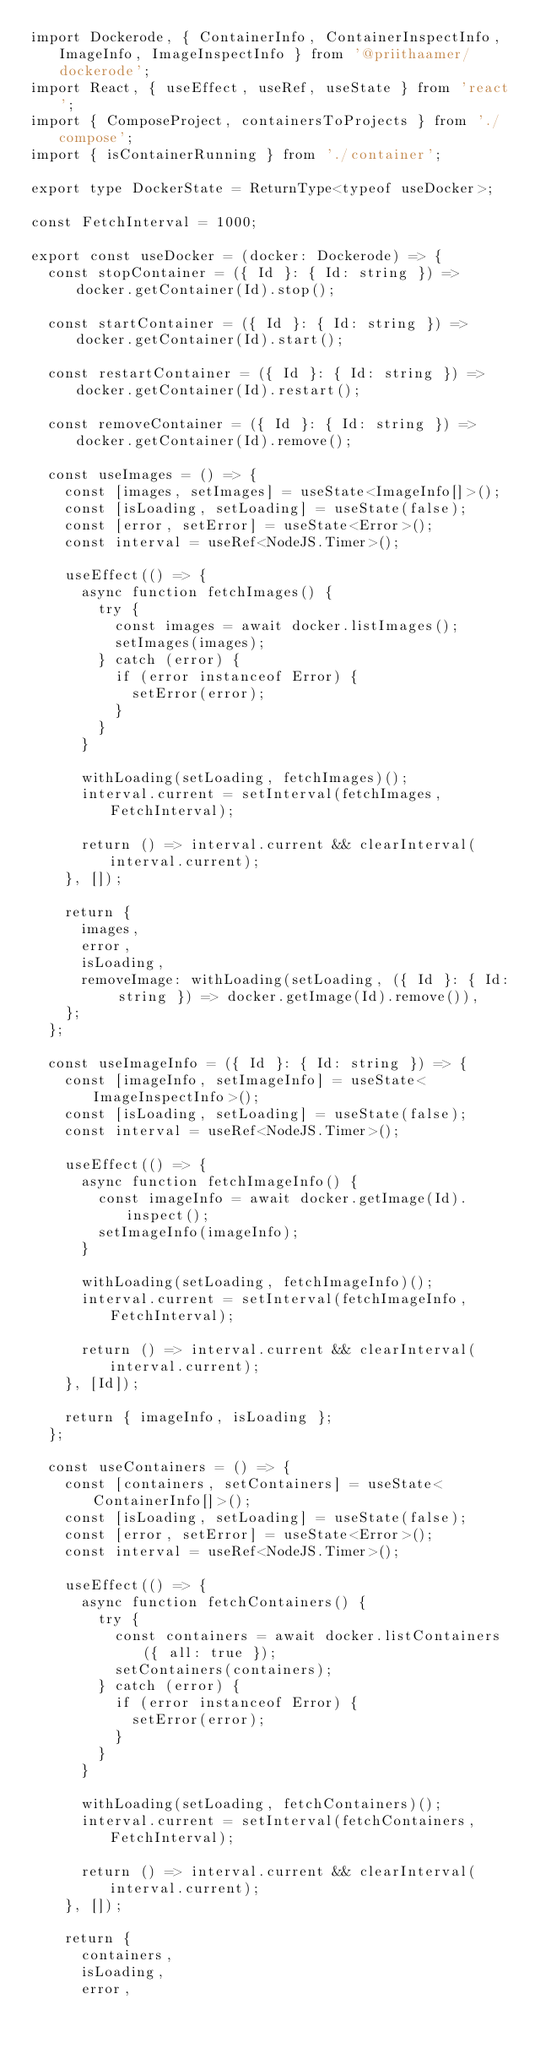<code> <loc_0><loc_0><loc_500><loc_500><_TypeScript_>import Dockerode, { ContainerInfo, ContainerInspectInfo, ImageInfo, ImageInspectInfo } from '@priithaamer/dockerode';
import React, { useEffect, useRef, useState } from 'react';
import { ComposeProject, containersToProjects } from './compose';
import { isContainerRunning } from './container';

export type DockerState = ReturnType<typeof useDocker>;

const FetchInterval = 1000;

export const useDocker = (docker: Dockerode) => {
  const stopContainer = ({ Id }: { Id: string }) => docker.getContainer(Id).stop();

  const startContainer = ({ Id }: { Id: string }) => docker.getContainer(Id).start();

  const restartContainer = ({ Id }: { Id: string }) => docker.getContainer(Id).restart();

  const removeContainer = ({ Id }: { Id: string }) => docker.getContainer(Id).remove();

  const useImages = () => {
    const [images, setImages] = useState<ImageInfo[]>();
    const [isLoading, setLoading] = useState(false);
    const [error, setError] = useState<Error>();
    const interval = useRef<NodeJS.Timer>();

    useEffect(() => {
      async function fetchImages() {
        try {
          const images = await docker.listImages();
          setImages(images);
        } catch (error) {
          if (error instanceof Error) {
            setError(error);
          }
        }
      }

      withLoading(setLoading, fetchImages)();
      interval.current = setInterval(fetchImages, FetchInterval);

      return () => interval.current && clearInterval(interval.current);
    }, []);

    return {
      images,
      error,
      isLoading,
      removeImage: withLoading(setLoading, ({ Id }: { Id: string }) => docker.getImage(Id).remove()),
    };
  };

  const useImageInfo = ({ Id }: { Id: string }) => {
    const [imageInfo, setImageInfo] = useState<ImageInspectInfo>();
    const [isLoading, setLoading] = useState(false);
    const interval = useRef<NodeJS.Timer>();

    useEffect(() => {
      async function fetchImageInfo() {
        const imageInfo = await docker.getImage(Id).inspect();
        setImageInfo(imageInfo);
      }

      withLoading(setLoading, fetchImageInfo)();
      interval.current = setInterval(fetchImageInfo, FetchInterval);

      return () => interval.current && clearInterval(interval.current);
    }, [Id]);

    return { imageInfo, isLoading };
  };

  const useContainers = () => {
    const [containers, setContainers] = useState<ContainerInfo[]>();
    const [isLoading, setLoading] = useState(false);
    const [error, setError] = useState<Error>();
    const interval = useRef<NodeJS.Timer>();

    useEffect(() => {
      async function fetchContainers() {
        try {
          const containers = await docker.listContainers({ all: true });
          setContainers(containers);
        } catch (error) {
          if (error instanceof Error) {
            setError(error);
          }
        }
      }

      withLoading(setLoading, fetchContainers)();
      interval.current = setInterval(fetchContainers, FetchInterval);

      return () => interval.current && clearInterval(interval.current);
    }, []);

    return {
      containers,
      isLoading,
      error,</code> 